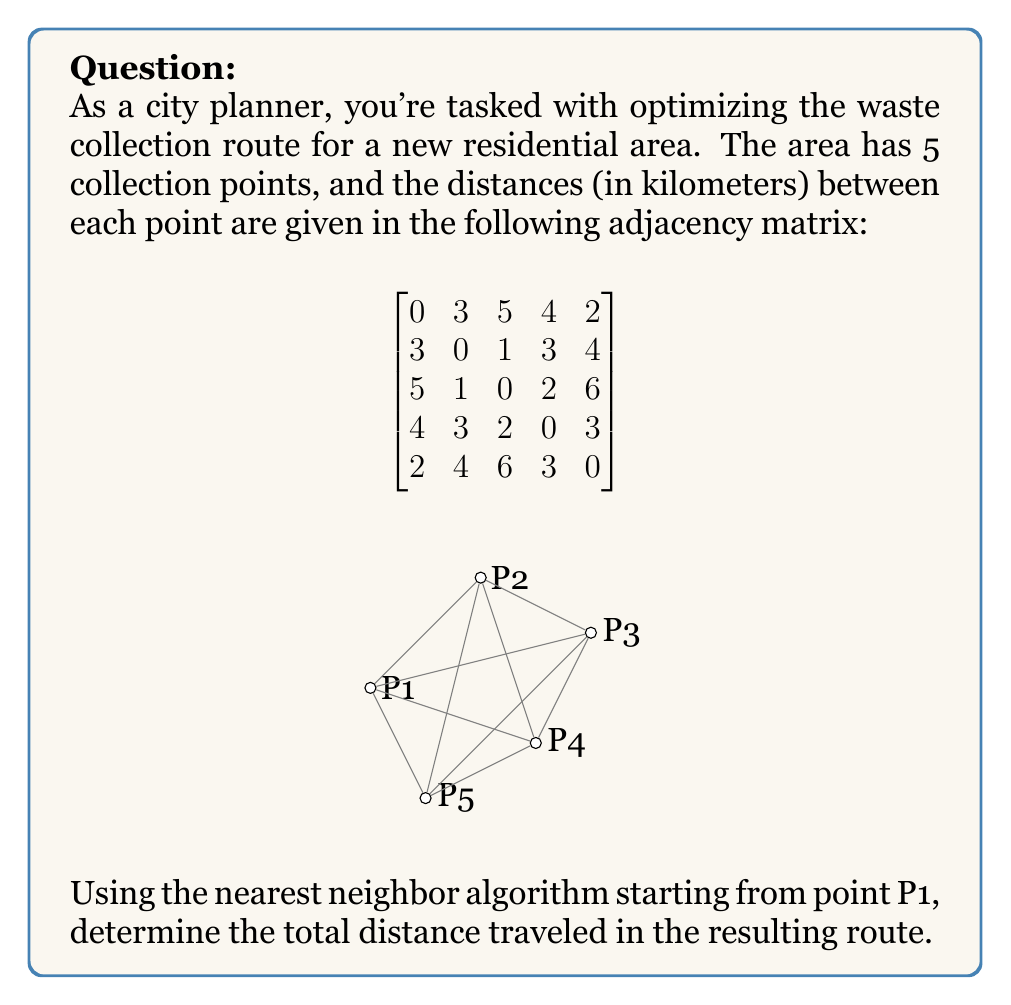Teach me how to tackle this problem. Let's solve this step-by-step using the nearest neighbor algorithm:

1) Start at P1 (row 1 in the matrix).
   Distance traveled so far: 0 km

2) Find the nearest unvisited neighbor to P1:
   P5 is closest with 2 km.
   Move to P5 (row 5 in the matrix).
   Distance traveled: 0 + 2 = 2 km

3) Find the nearest unvisited neighbor to P5:
   P1 is already visited, so P4 is closest with 3 km.
   Move to P4 (row 4 in the matrix).
   Distance traveled: 2 + 3 = 5 km

4) Find the nearest unvisited neighbor to P4:
   P2 and P3 are both 3 km away. We'll choose P2 arbitrarily.
   Move to P2 (row 2 in the matrix).
   Distance traveled: 5 + 3 = 8 km

5) Only P3 is left unvisited.
   Move to P3.
   Distance from P2 to P3 is 1 km.
   Distance traveled: 8 + 1 = 9 km

6) To complete the tour, return to P1.
   Distance from P3 to P1 is 5 km.
   Total distance traveled: 9 + 5 = 14 km

The resulting route is: P1 → P5 → P4 → P2 → P3 → P1
Answer: 14 km 